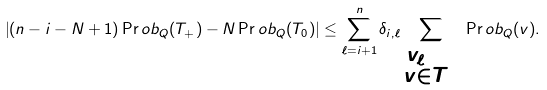<formula> <loc_0><loc_0><loc_500><loc_500>\left | ( n - i - N + 1 ) \Pr o b _ { Q } ( T _ { + } ) - N \Pr o b _ { Q } ( T _ { 0 } ) \right | \leq \sum _ { \ell = i + 1 } ^ { n } \delta _ { i , \ell } \sum _ { \substack { v _ { \ell } = 0 \\ v \in T _ { + } } } \, \Pr o b _ { Q } ( v ) .</formula> 